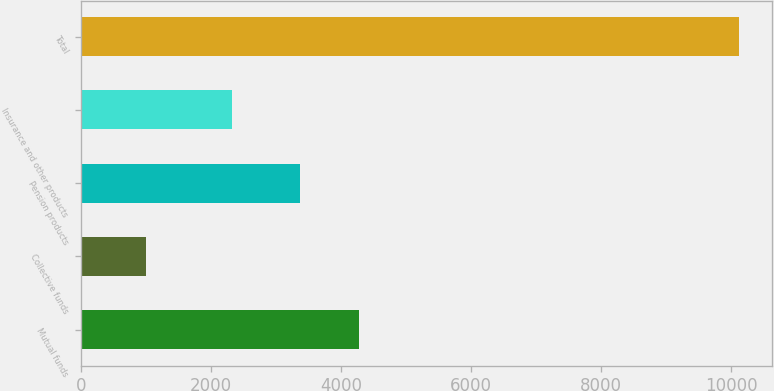Convert chart to OTSL. <chart><loc_0><loc_0><loc_500><loc_500><bar_chart><fcel>Mutual funds<fcel>Collective funds<fcel>Pension products<fcel>Insurance and other products<fcel>Total<nl><fcel>4270<fcel>1001<fcel>3358<fcel>2320<fcel>10121<nl></chart> 